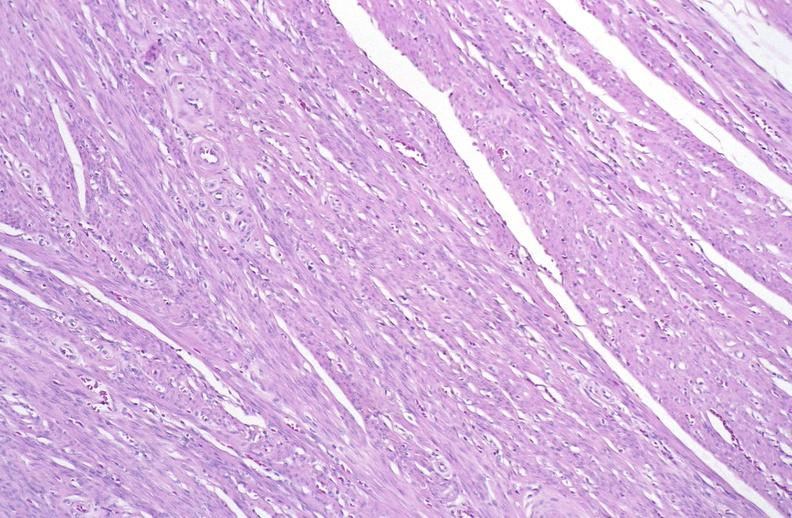s metastatic carcinoma present?
Answer the question using a single word or phrase. No 